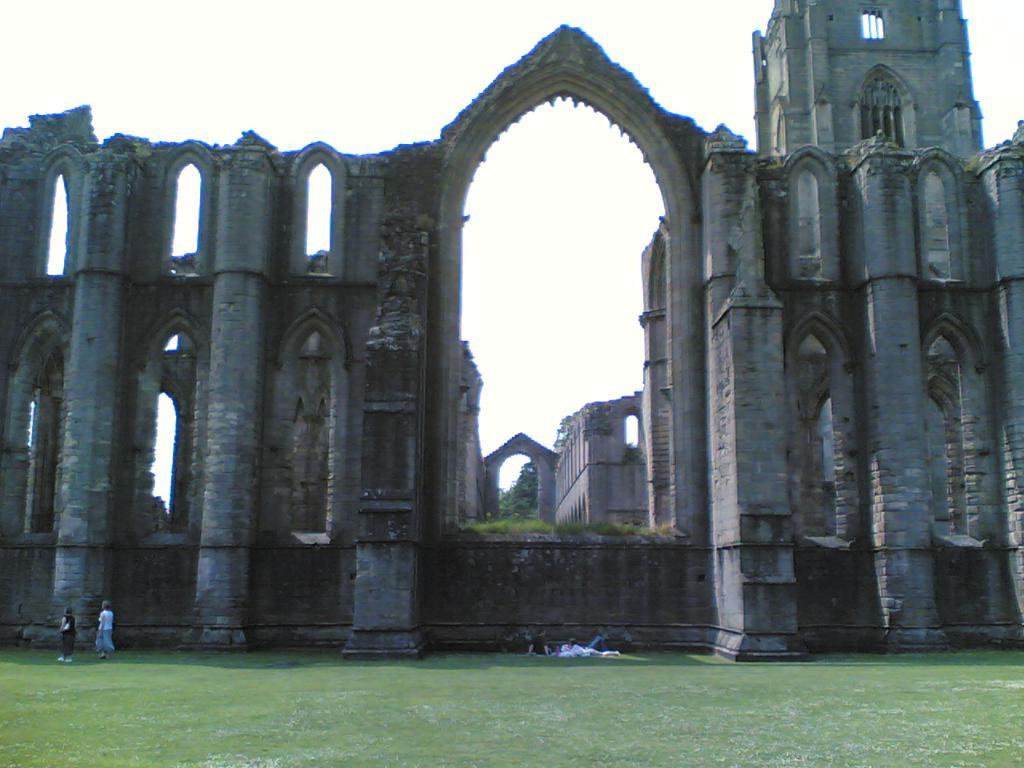What is the main structure in the image? There is a castle in the image. What can be seen in the foreground of the image? There is a ground in the foreground of the image. What are the people in the image doing? There are people walking and sitting on the ground in the image. How would you describe the sky in the image? The sky is clear in the image. What is the queen's rate of brushing her teeth in the image? There is no queen or any mention of brushing teeth in the image. 